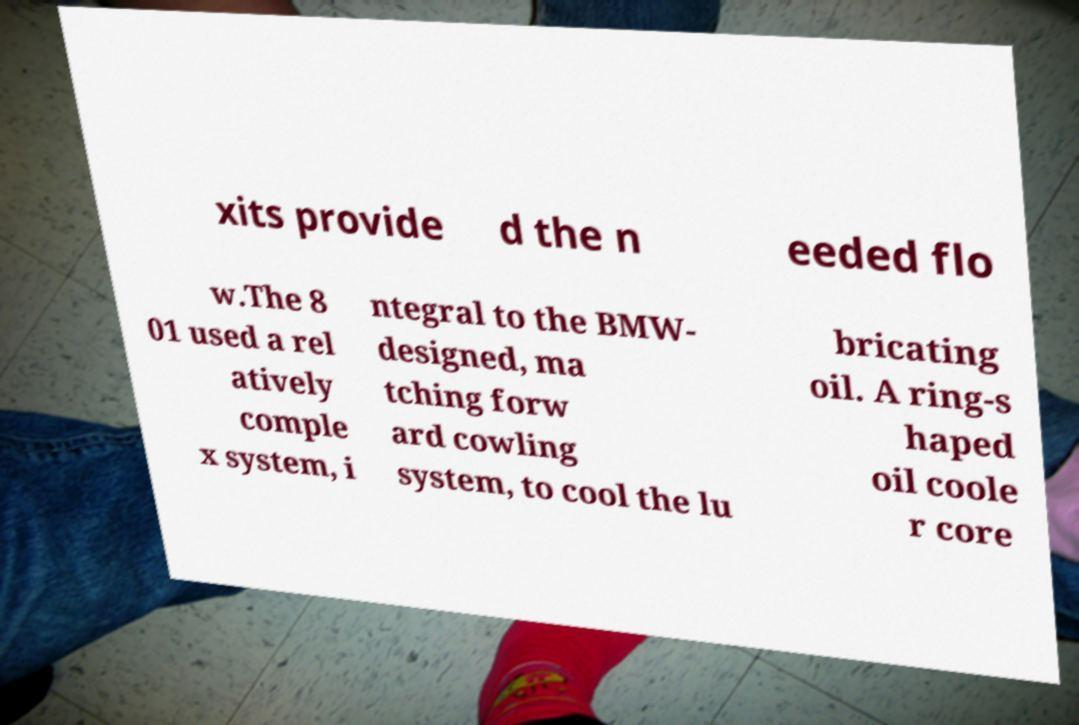Please identify and transcribe the text found in this image. xits provide d the n eeded flo w.The 8 01 used a rel atively comple x system, i ntegral to the BMW- designed, ma tching forw ard cowling system, to cool the lu bricating oil. A ring-s haped oil coole r core 